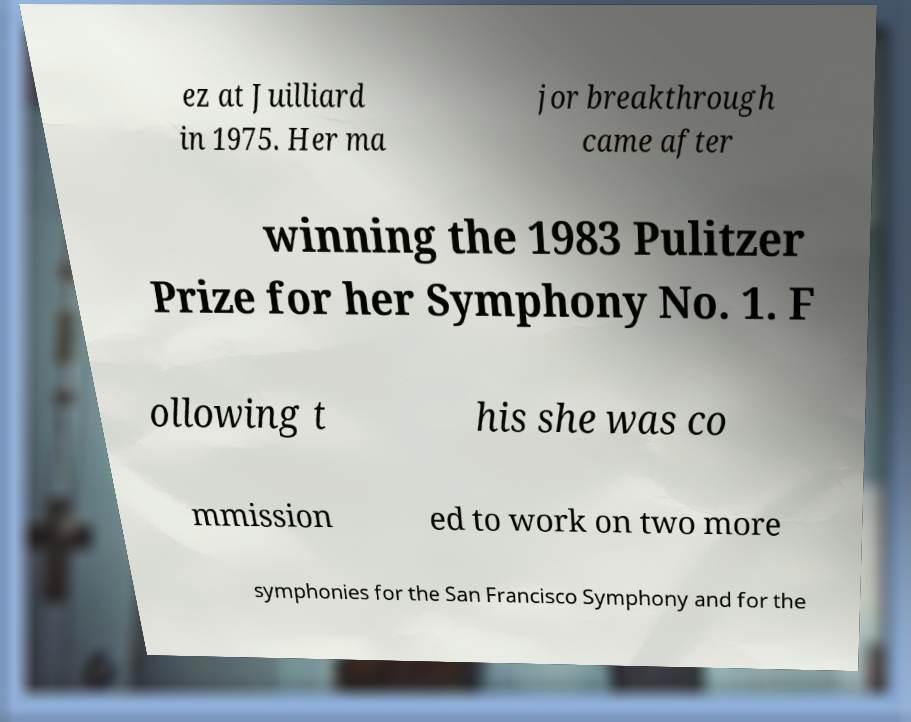I need the written content from this picture converted into text. Can you do that? ez at Juilliard in 1975. Her ma jor breakthrough came after winning the 1983 Pulitzer Prize for her Symphony No. 1. F ollowing t his she was co mmission ed to work on two more symphonies for the San Francisco Symphony and for the 